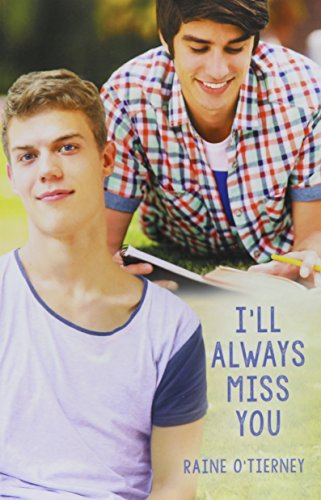Is this book related to Teen & Young Adult? Yes, this book is certainly within the 'Teen & Young Adult' genre, as it deals with themes and stories suitable for young adult readers. 